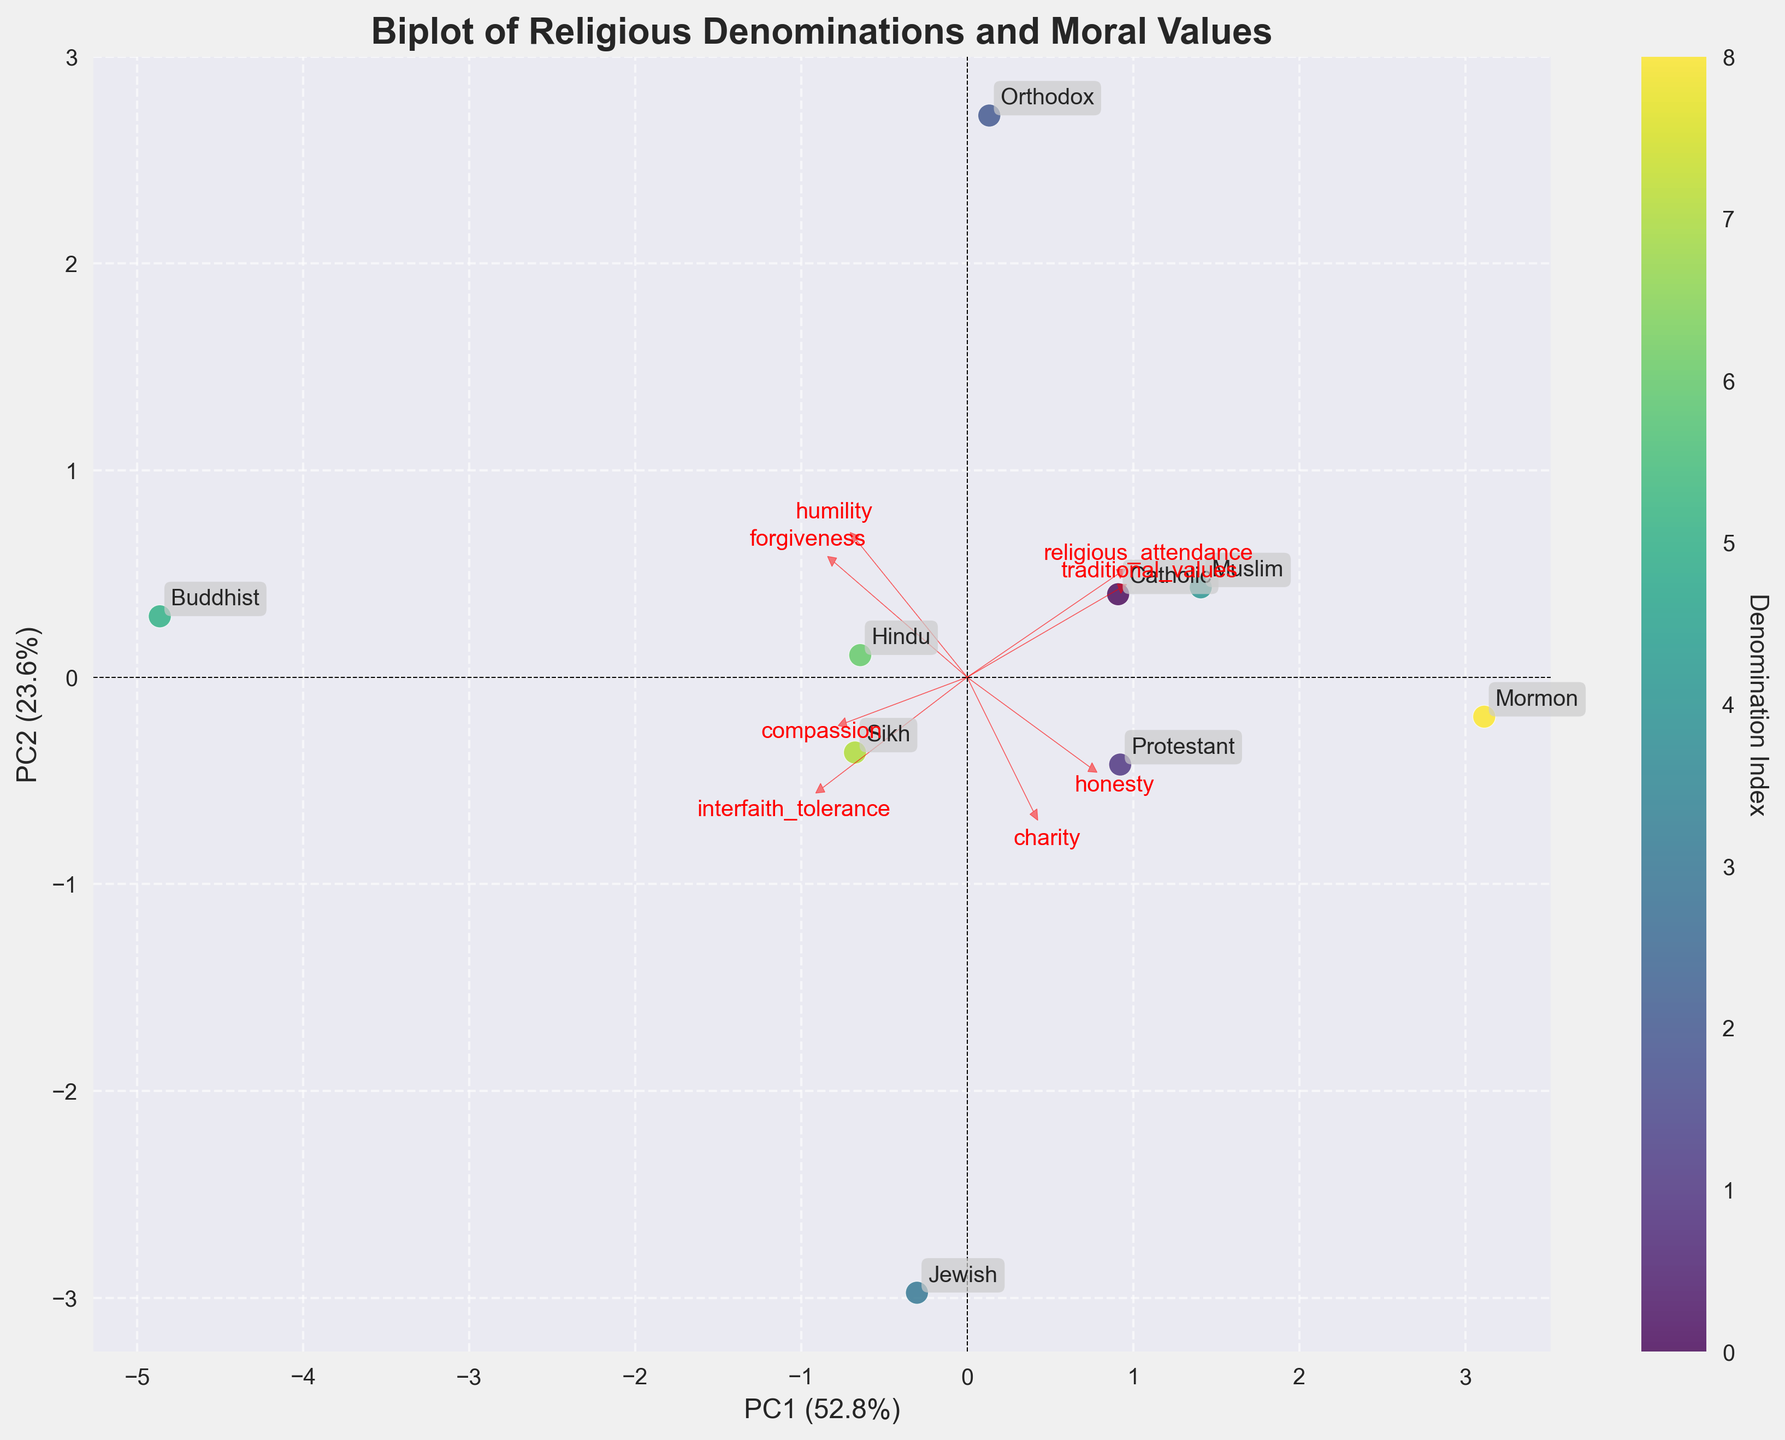What is the title of the figure? The answer can be found at the top of the figure. It states, "Biplot of Religious Denominations and Moral Values".
Answer: Biplot of Religious Denominations and Moral Values How many denominations are represented in the biplot? By counting the number of unique labels annotated around the data points, you can determine the number of denominations. There are 9 labels.
Answer: 9 Which denomination has the highest value on the PC1 axis? Observe the positions of the data points along the PC1 axis. The denomination farthest to the right on the PC1 axis represents the highest value on this axis. The Orthodox denomination is farthest to the right.
Answer: Orthodox Which moral value has the strongest loading on the PC2 axis? Find the arrows representing the loadings and identify which arrow extends the furthest vertically. This will indicate the strongest loading on the PC2 axis. The value that has the arrow extending furthest vertically is "Interfaith Tolerance".
Answer: Interfaith Tolerance How do the Catholic and Protestant denominations compare on the PC1 and PC2 axes? Look at the positions of the data points for Catholic and Protestant. Protestant is slightly to the right and higher than Catholic on the axes. This shows Protestant has a higher value on both PC1 and PC2.
Answer: Protestant is higher on both axes Which feature is shown to be least correlated with the PC1 axis? Identify the arrow that aligns closest to the horizontal line around the PC1 axis, indicating minimal variance in that direction. The feature with the arrow closest horizontally is "Humility".
Answer: Humility Which denominations are closest together on the biplot? Analyze the scatter of the data points and find denominations that are nearest to each other. Catholic and Protestant are positioned closest together in the plot.
Answer: Catholic and Protestant What percentage of variance is explained by the first principal component (PC1)? The explanation percentage of PC1 is labeled on the x-axis of the plot. It shows 37.8%.
Answer: 37.8% Is "Traditional Values" more correlated with PC1 or PC2? The positioning and direction of the "Traditional Values" arrow indicate its relative correlation. Since the arrow is more horizontally extended, it is more correlated with PC1.
Answer: PC1 